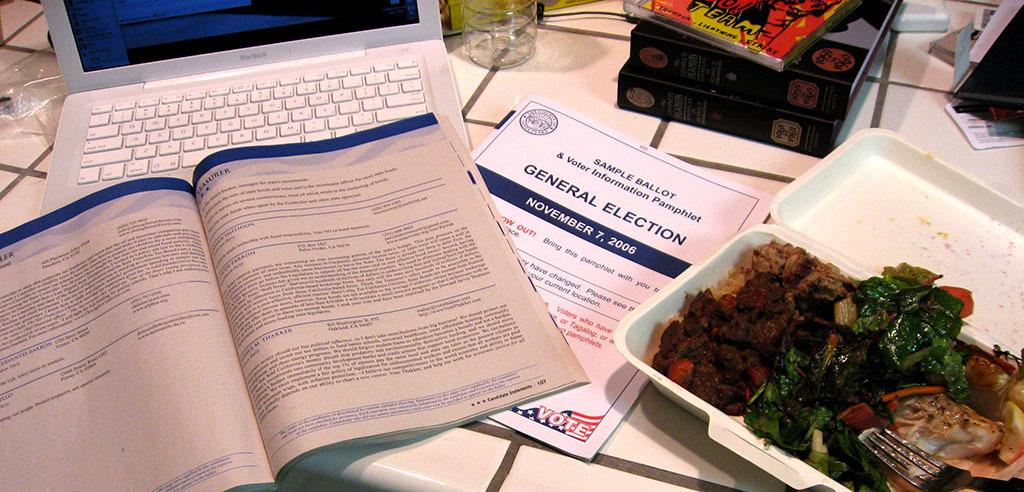<image>
Relay a brief, clear account of the picture shown. A laptop sits open with a sample Ballot for a general election next to it and another document in front of it. 